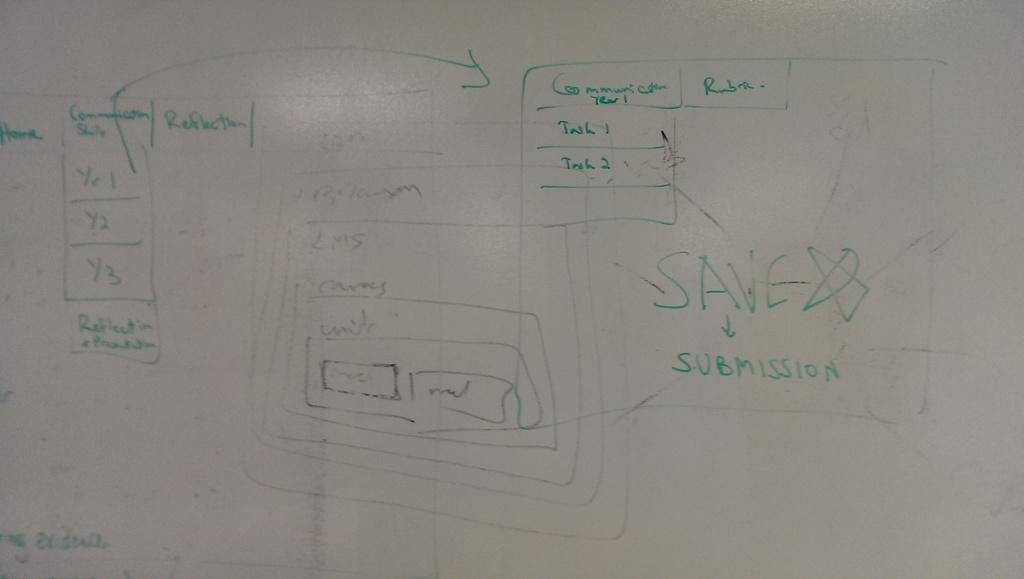Provide a one-sentence caption for the provided image. A whiteboard covered in green marker drawings and the word save written above the word submission. 